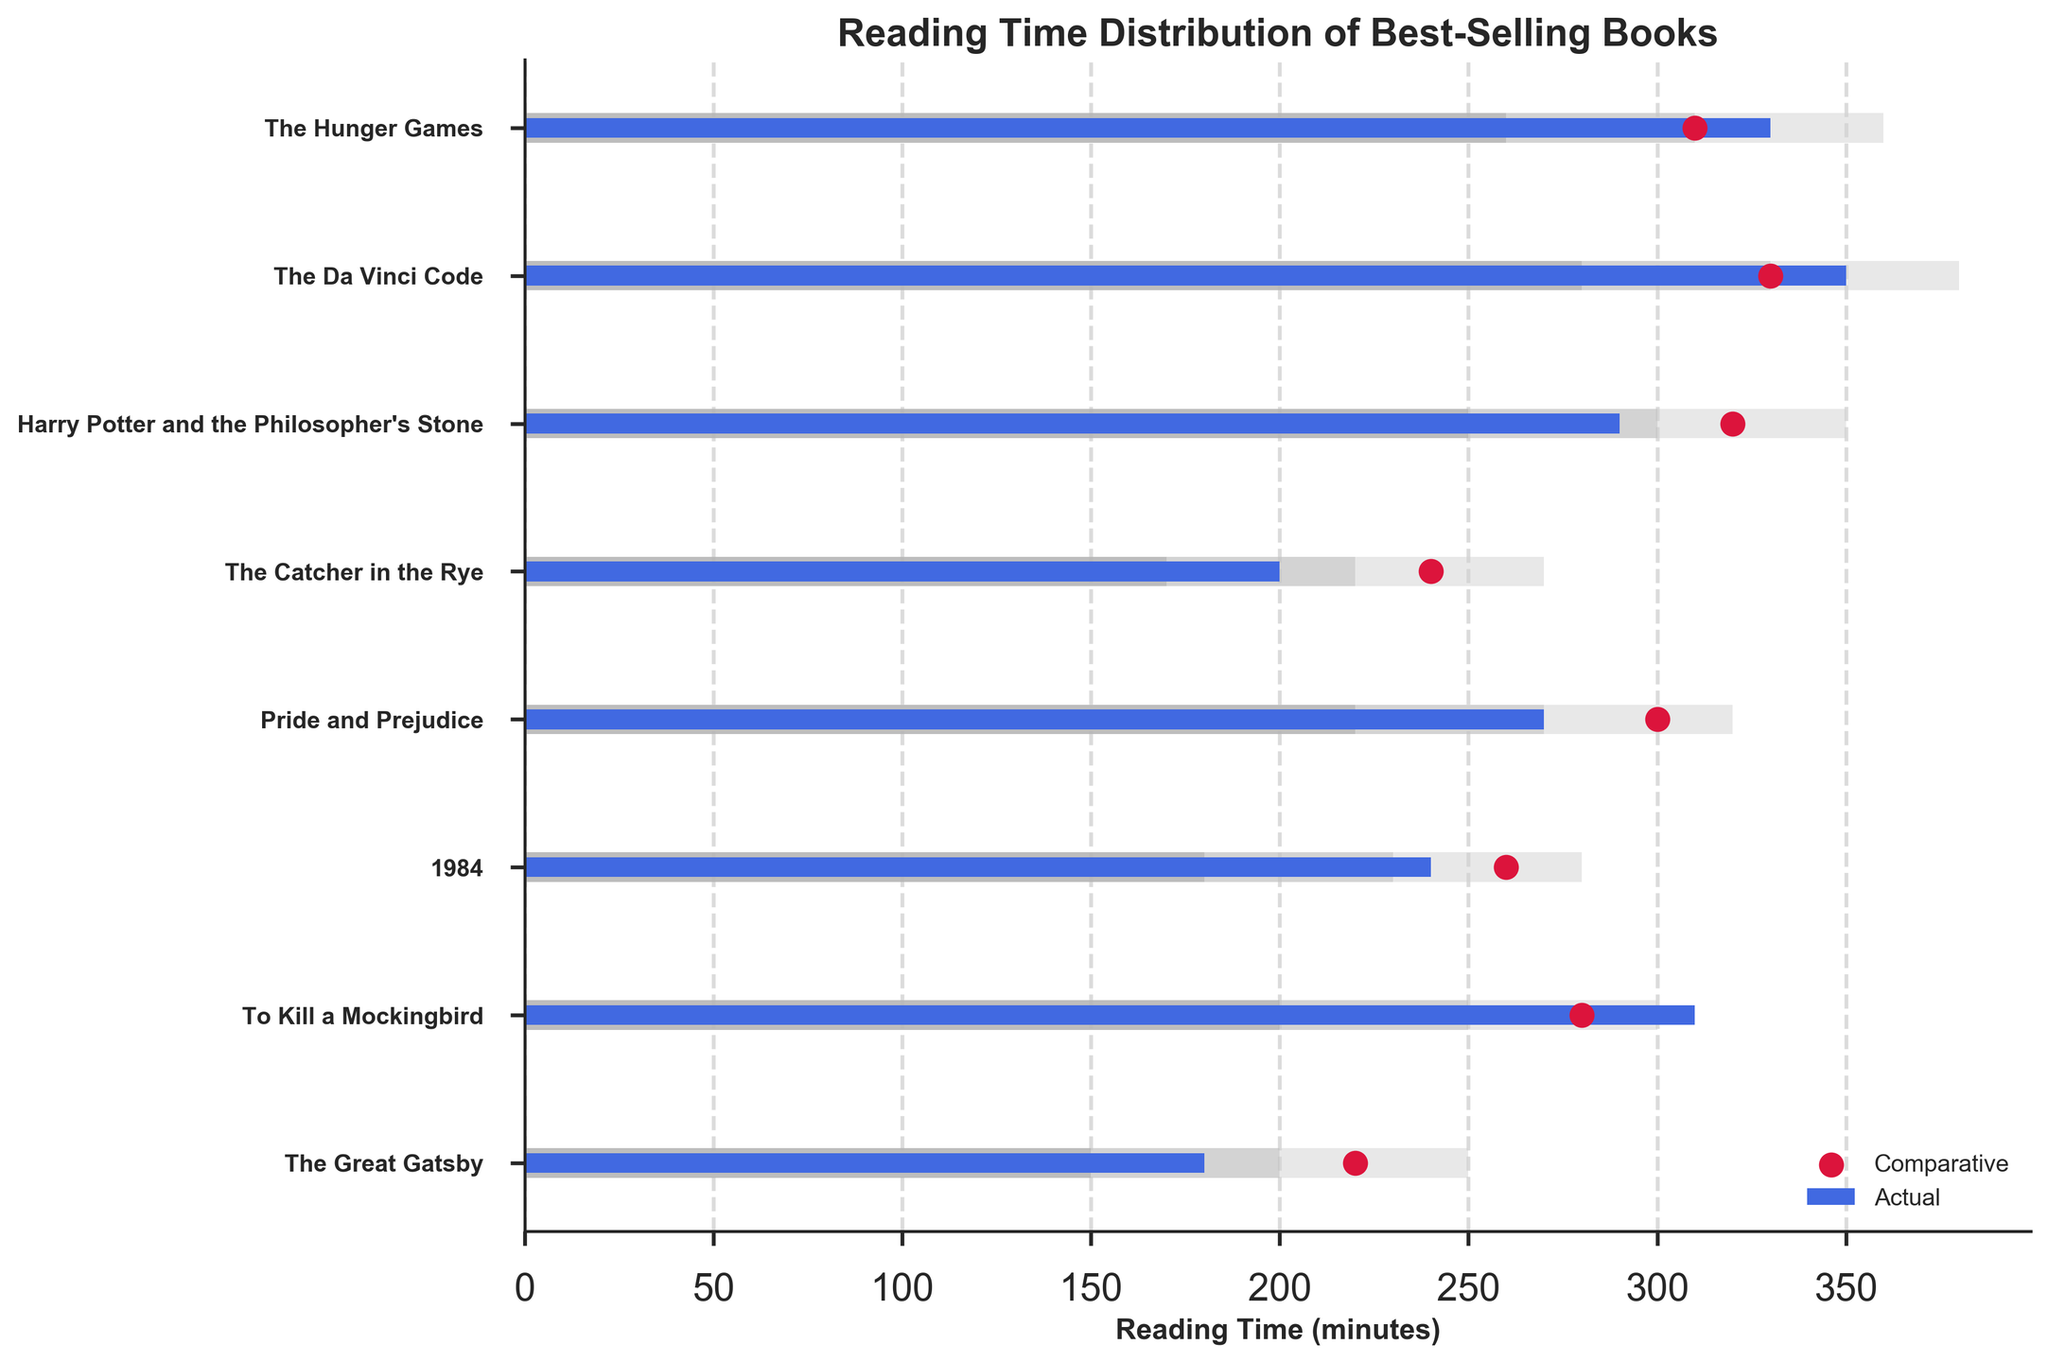What is the title of the chart? The title of the chart is typically found at the top of the figure and provides a summary of what the chart depicts. In this case, the title is clearly stated above the chart area.
Answer: Reading Time Distribution of Best-Selling Books Which book has the longest actual reading time? The actual reading time for each book is represented by the horizontal blue bars. The longest bar represents the book with the longest reading time.
Answer: The Da Vinci Code Which book has the shortest actual reading time? Similar to the longest reading time, you can identify the shortest reading time by looking for the shortest blue bar in the visual.
Answer: The Great Gatsby How does the reading time of "1984" compare to the industry average? For "1984," compare the length of the blue bar (actual reading time) with the position of the red dot (industry average) on the same horizontal line. The actual value is slightly below the industry average.
Answer: Less than the industry average Which books have an actual reading time greater than their comparative (industry average) reading time? Check the relative positions of the blue bars and red dots. Books where the blue bar extends beyond the position of the red dot have a greater actual reading time compared to the industry average.
Answer: To Kill a Mockingbird, The Da Vinci Code, The Hunger Games What is the range of reading times for "Pride and Prejudice"? The range is indicated by the width of the color-coded bars. The minimum range is shown by the shortest gray bar, and the maximum range is shown by the longest light grey bar.
Answer: 220 to 320 minutes Which book falls within the first range (dark grey) but below the comparative average? Identify the book where the actual value (blue bar) falls within the dark grey range but does not reach the red dot.
Answer: The Catcher in the Rye Which book has the smallest difference between its actual reading time and the industry average? Calculate or visually estimate the difference between the length of the blue bar and the position of the red dot for each book, then identify the smallest gap.
Answer: 1984 What can you infer from the comparative (industry average) reading times of "Harry Potter and the Philosopher's Stone" and "The Da Vinci Code"? Compare the positions of the red dots for both books to infer if one has a higher or lower industry average reading time than the other.
Answer: The Da Vinci Code has a lower comparative reading time than Harry Potter and the Philosopher's Stone Provide an example of a book with an actual reading time within the second range (silver). The second range is indicated by the silver bar. Identify a book where the blue bar falls within this silver area.
Answer: 1984 